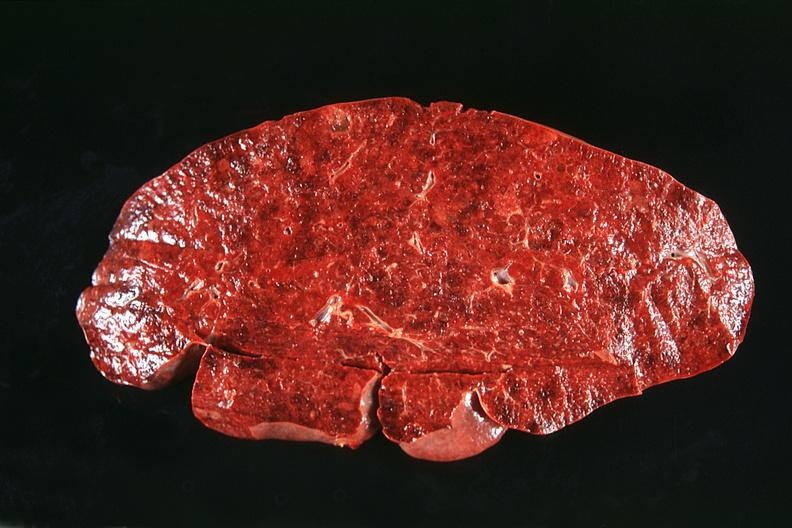does this image show spleen, normal?
Answer the question using a single word or phrase. Yes 